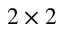<formula> <loc_0><loc_0><loc_500><loc_500>2 \times 2</formula> 